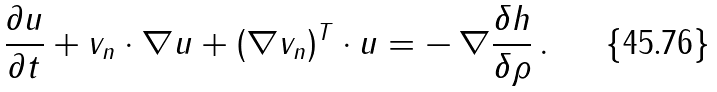Convert formula to latex. <formula><loc_0><loc_0><loc_500><loc_500>\frac { \partial u } { \partial { t } } + v _ { n } \cdot \nabla u + ( \nabla v _ { n } ) ^ { T } \cdot u = - \, \nabla \frac { \delta h } { \delta \rho } \, .</formula> 